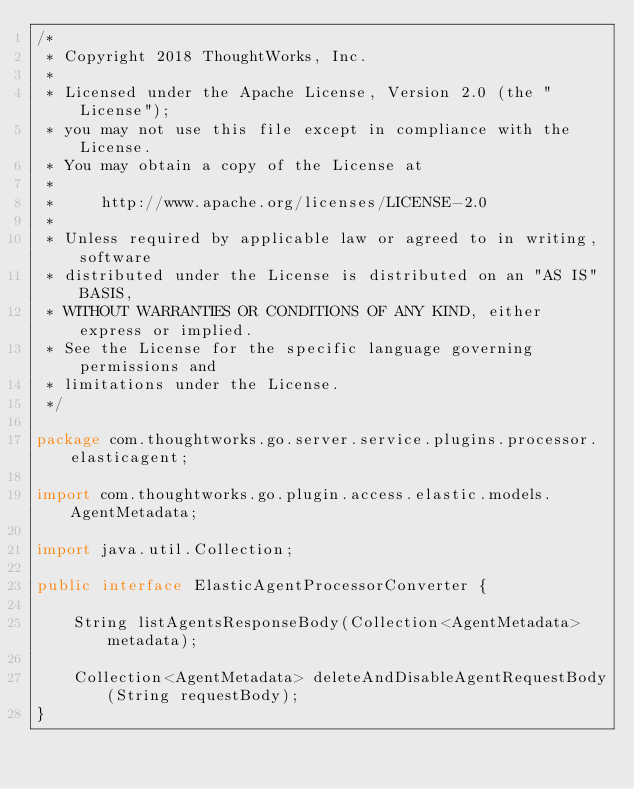Convert code to text. <code><loc_0><loc_0><loc_500><loc_500><_Java_>/*
 * Copyright 2018 ThoughtWorks, Inc.
 *
 * Licensed under the Apache License, Version 2.0 (the "License");
 * you may not use this file except in compliance with the License.
 * You may obtain a copy of the License at
 *
 *     http://www.apache.org/licenses/LICENSE-2.0
 *
 * Unless required by applicable law or agreed to in writing, software
 * distributed under the License is distributed on an "AS IS" BASIS,
 * WITHOUT WARRANTIES OR CONDITIONS OF ANY KIND, either express or implied.
 * See the License for the specific language governing permissions and
 * limitations under the License.
 */

package com.thoughtworks.go.server.service.plugins.processor.elasticagent;

import com.thoughtworks.go.plugin.access.elastic.models.AgentMetadata;

import java.util.Collection;

public interface ElasticAgentProcessorConverter {

    String listAgentsResponseBody(Collection<AgentMetadata> metadata);

    Collection<AgentMetadata> deleteAndDisableAgentRequestBody(String requestBody);
}
</code> 